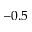Convert formula to latex. <formula><loc_0><loc_0><loc_500><loc_500>- 0 . 5</formula> 